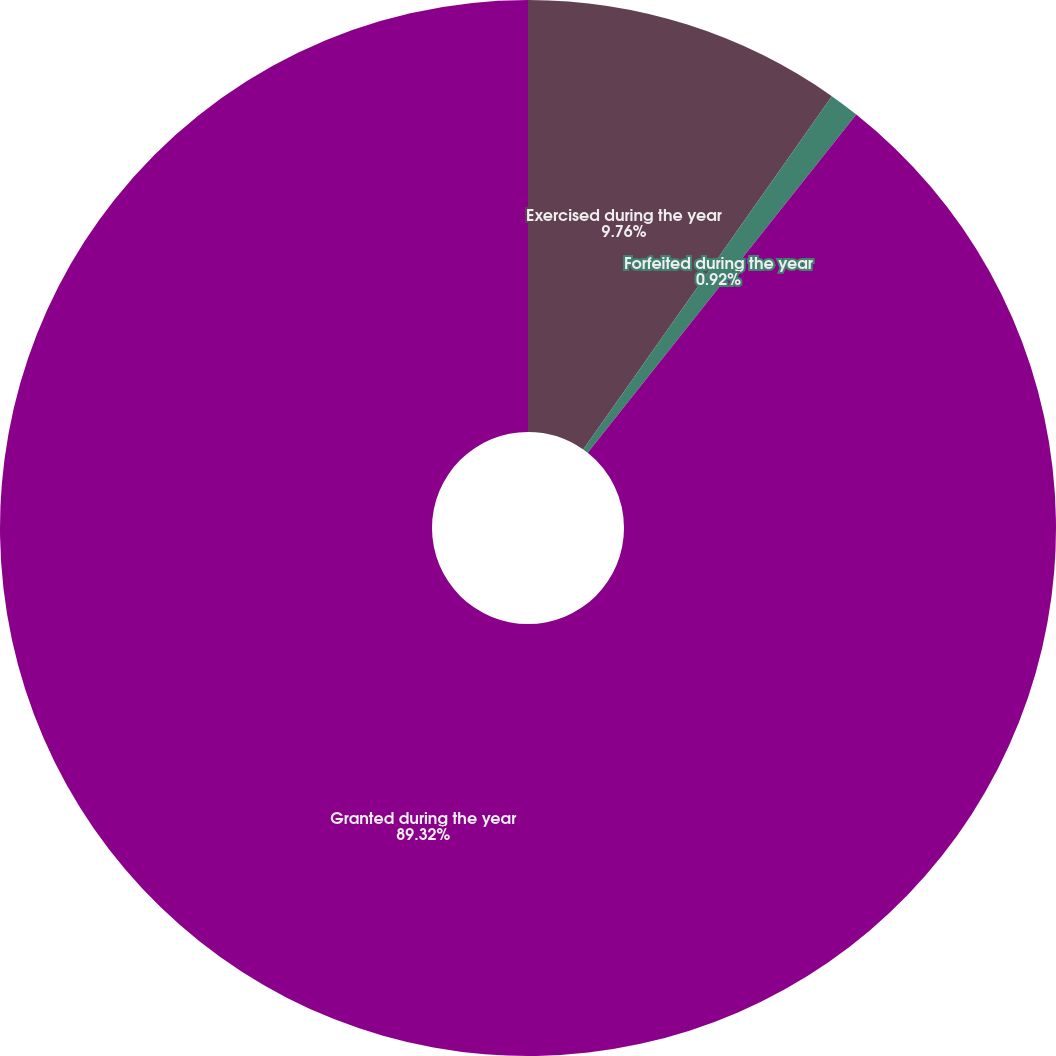<chart> <loc_0><loc_0><loc_500><loc_500><pie_chart><fcel>Exercised during the year<fcel>Forfeited during the year<fcel>Granted during the year<nl><fcel>9.76%<fcel>0.92%<fcel>89.33%<nl></chart> 